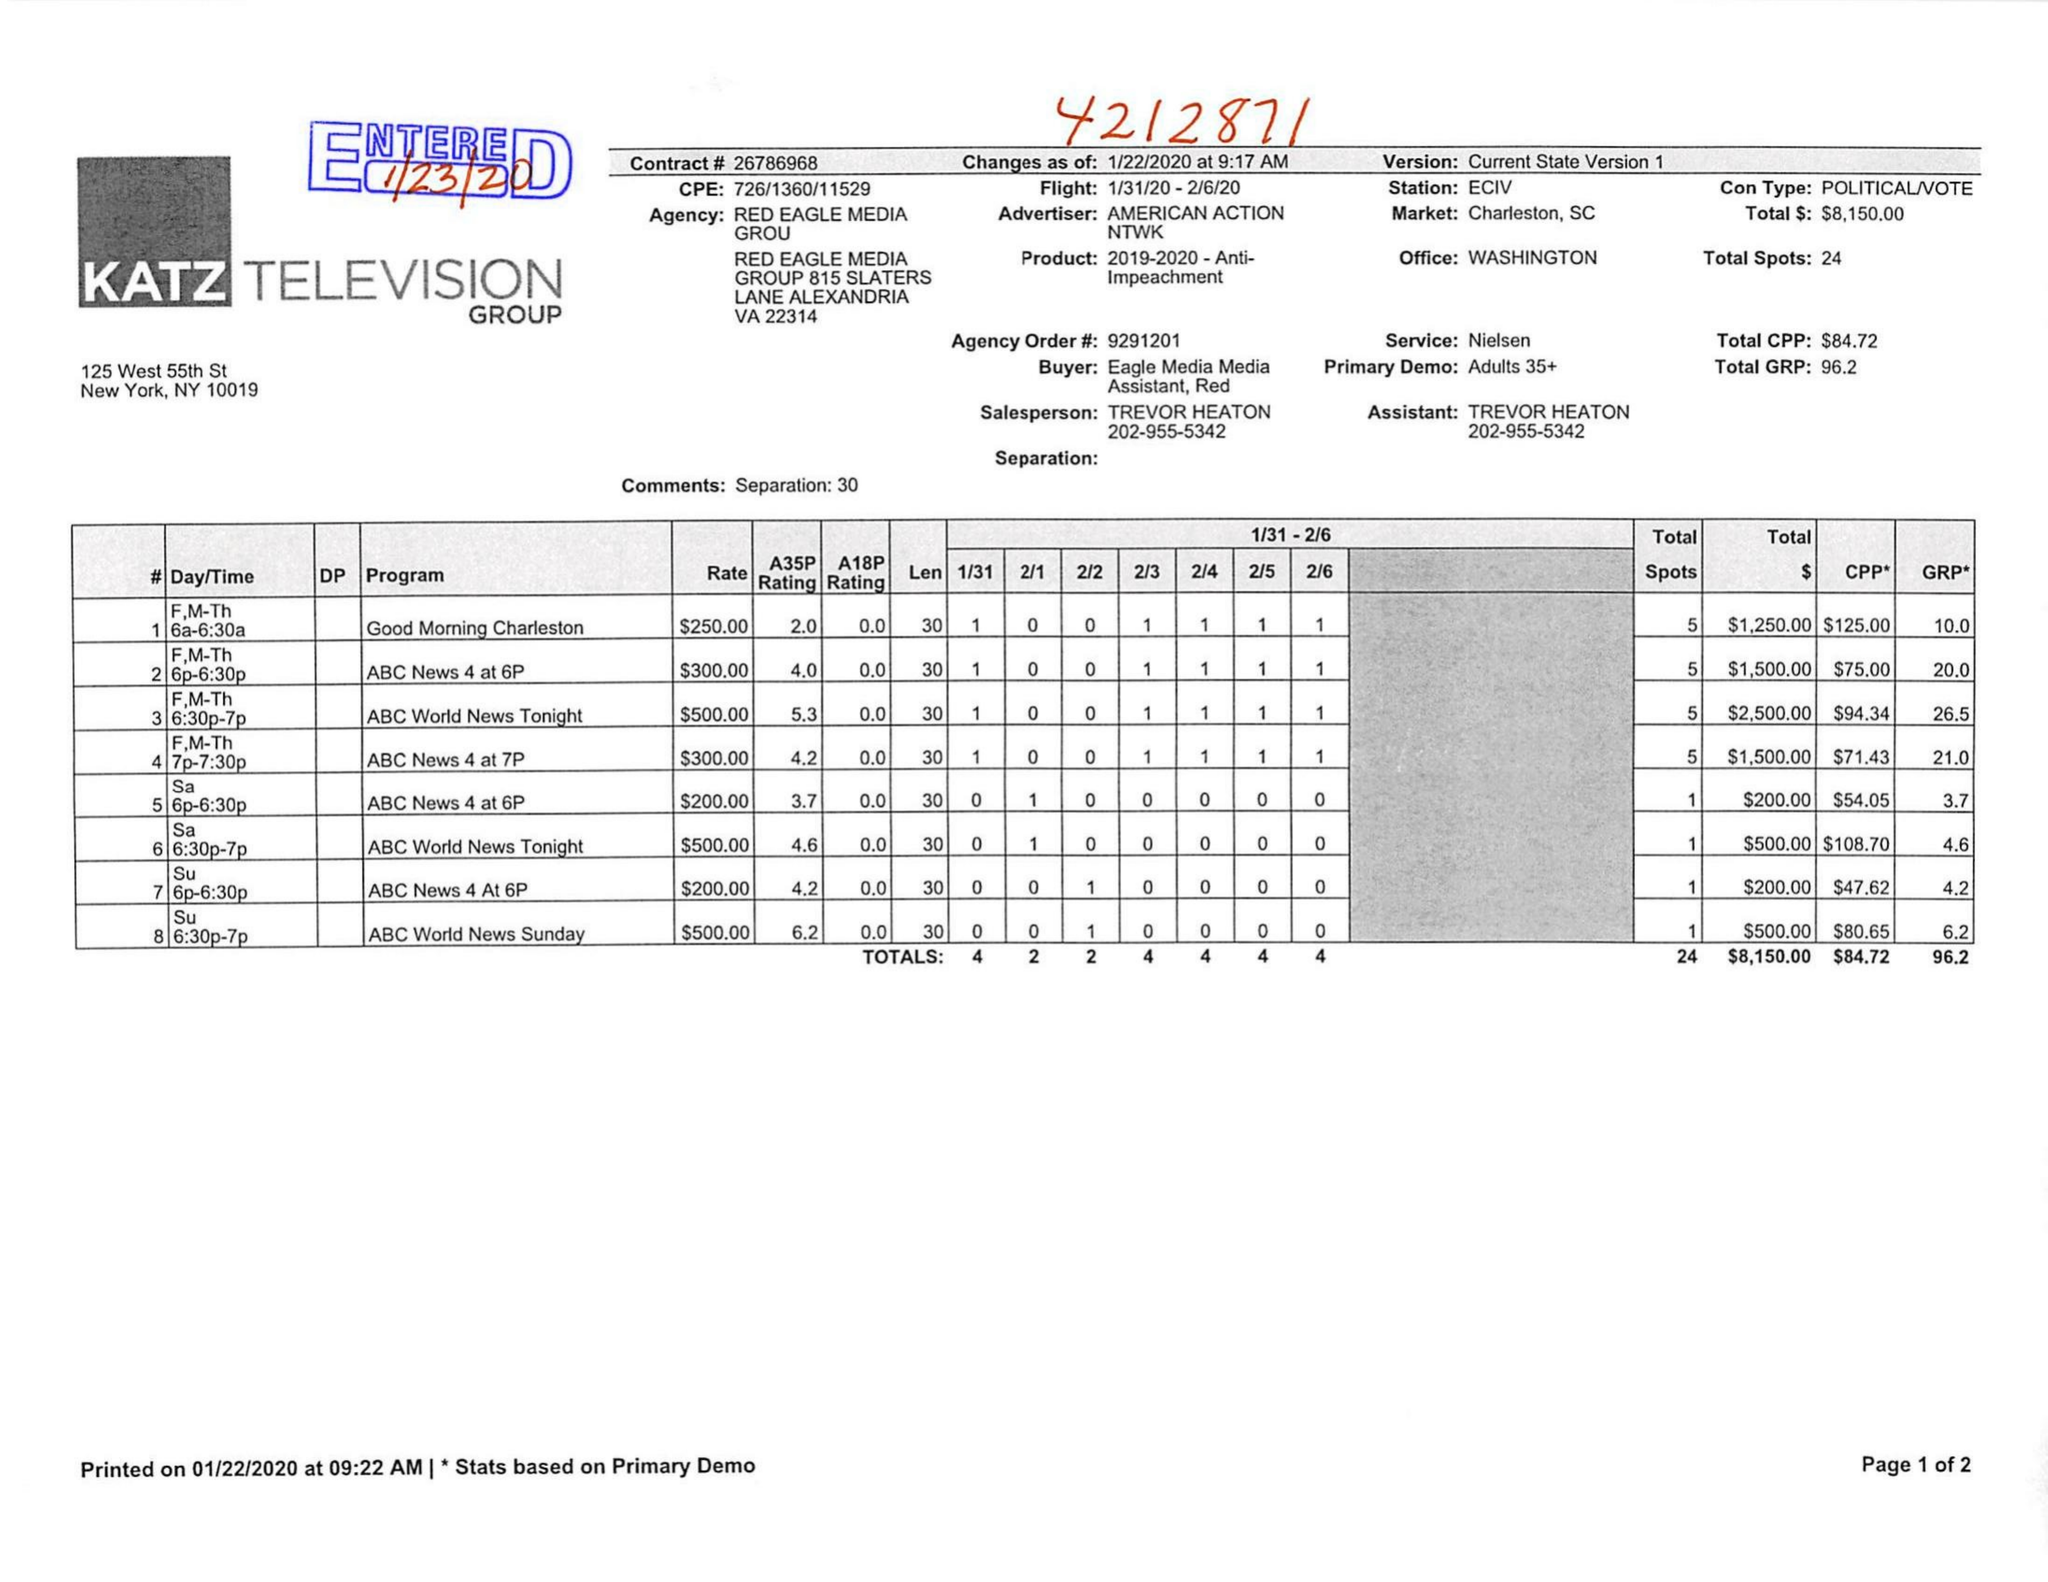What is the value for the flight_to?
Answer the question using a single word or phrase. 02/06/20 